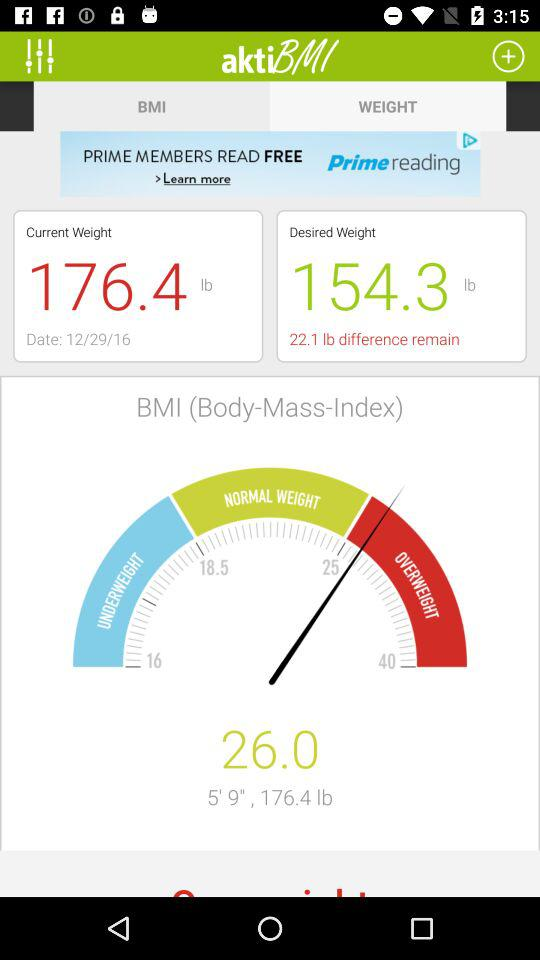What is the current weight date? The date is December 29, 2016. 